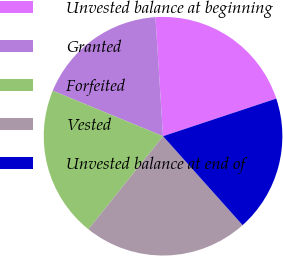<chart> <loc_0><loc_0><loc_500><loc_500><pie_chart><fcel>Unvested balance at beginning<fcel>Granted<fcel>Forfeited<fcel>Vested<fcel>Unvested balance at end of<nl><fcel>20.91%<fcel>17.76%<fcel>20.46%<fcel>22.37%<fcel>18.49%<nl></chart> 